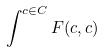Convert formula to latex. <formula><loc_0><loc_0><loc_500><loc_500>\int ^ { c \in C } F ( c , c )</formula> 